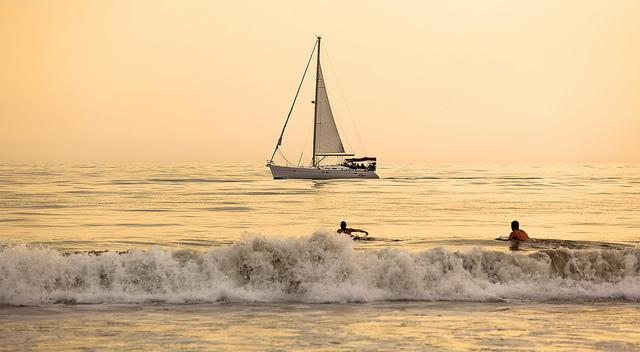What natural feature do the surfers like but the sailors of the boat here hate? Please explain your reasoning. big waves. Surfers love huge ocean waves but people on sailboats hate them. 